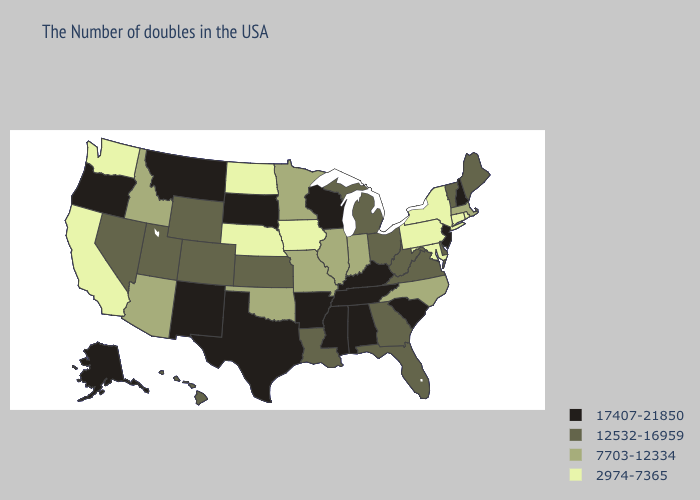What is the lowest value in states that border Tennessee?
Be succinct. 7703-12334. What is the lowest value in states that border Illinois?
Quick response, please. 2974-7365. Does Mississippi have the lowest value in the South?
Keep it brief. No. What is the highest value in the South ?
Keep it brief. 17407-21850. How many symbols are there in the legend?
Write a very short answer. 4. Does Kansas have the highest value in the USA?
Answer briefly. No. Does the first symbol in the legend represent the smallest category?
Short answer required. No. Name the states that have a value in the range 7703-12334?
Answer briefly. Massachusetts, North Carolina, Indiana, Illinois, Missouri, Minnesota, Oklahoma, Arizona, Idaho. What is the value of Louisiana?
Keep it brief. 12532-16959. Which states have the highest value in the USA?
Quick response, please. New Hampshire, New Jersey, South Carolina, Kentucky, Alabama, Tennessee, Wisconsin, Mississippi, Arkansas, Texas, South Dakota, New Mexico, Montana, Oregon, Alaska. What is the value of Washington?
Short answer required. 2974-7365. Which states have the lowest value in the MidWest?
Write a very short answer. Iowa, Nebraska, North Dakota. Does the map have missing data?
Keep it brief. No. Does Nebraska have the highest value in the USA?
Concise answer only. No. 